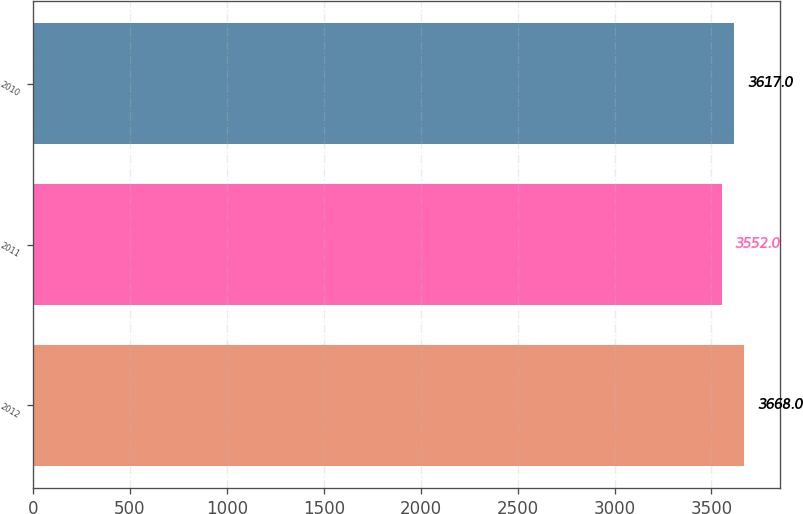Convert chart. <chart><loc_0><loc_0><loc_500><loc_500><bar_chart><fcel>2012<fcel>2011<fcel>2010<nl><fcel>3668<fcel>3552<fcel>3617<nl></chart> 